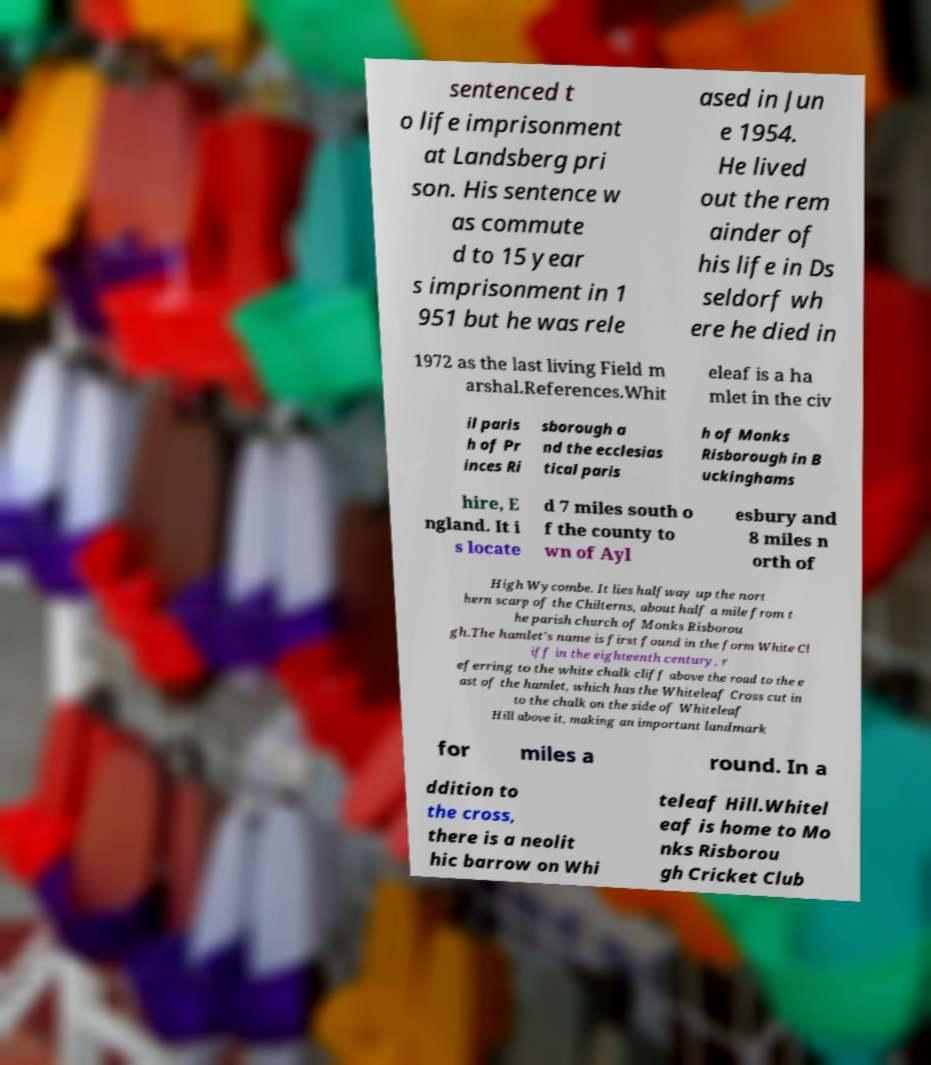Please identify and transcribe the text found in this image. sentenced t o life imprisonment at Landsberg pri son. His sentence w as commute d to 15 year s imprisonment in 1 951 but he was rele ased in Jun e 1954. He lived out the rem ainder of his life in Ds seldorf wh ere he died in 1972 as the last living Field m arshal.References.Whit eleaf is a ha mlet in the civ il paris h of Pr inces Ri sborough a nd the ecclesias tical paris h of Monks Risborough in B uckinghams hire, E ngland. It i s locate d 7 miles south o f the county to wn of Ayl esbury and 8 miles n orth of High Wycombe. It lies halfway up the nort hern scarp of the Chilterns, about half a mile from t he parish church of Monks Risborou gh.The hamlet's name is first found in the form White Cl iff in the eighteenth century, r eferring to the white chalk cliff above the road to the e ast of the hamlet, which has the Whiteleaf Cross cut in to the chalk on the side of Whiteleaf Hill above it, making an important landmark for miles a round. In a ddition to the cross, there is a neolit hic barrow on Whi teleaf Hill.Whitel eaf is home to Mo nks Risborou gh Cricket Club 